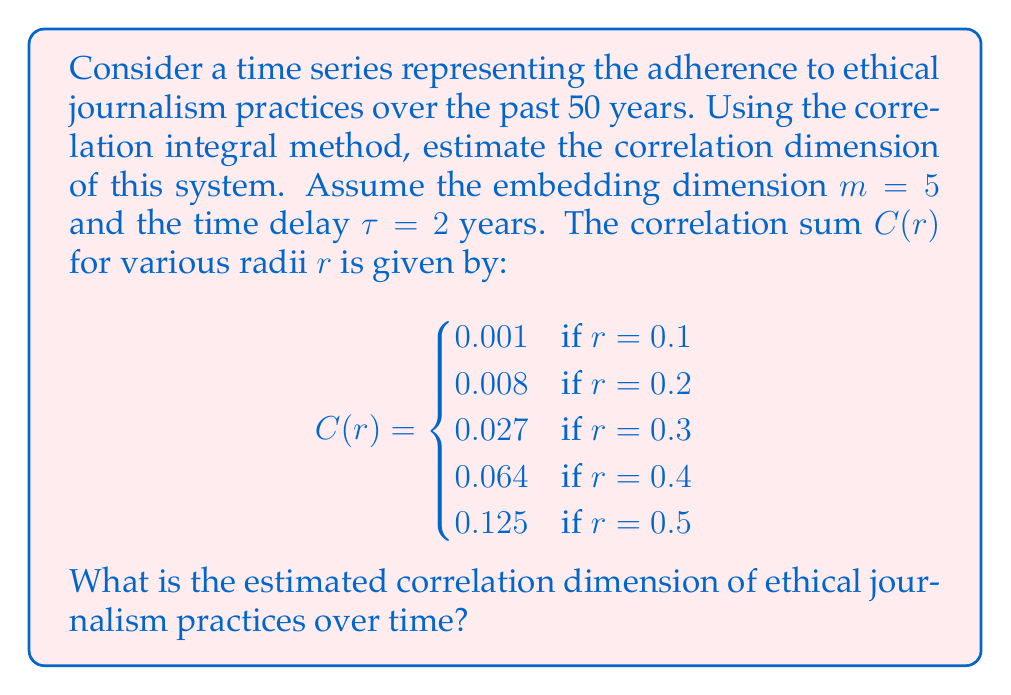Teach me how to tackle this problem. To estimate the correlation dimension, we'll follow these steps:

1) The correlation dimension $D_2$ is defined as:

   $$D_2 = \lim_{r \to 0} \frac{\log C(r)}{\log r}$$

2) In practice, we estimate this by plotting $\log C(r)$ against $\log r$ and finding the slope of the linear portion.

3) Let's calculate $\log C(r)$ and $\log r$ for each given point:

   $$\begin{array}{c|c|c}
   r & \log r & \log C(r) \\
   \hline
   0.1 & -2.3026 & -6.9078 \\
   0.2 & -1.6094 & -4.8283 \\
   0.3 & -1.2040 & -3.6119 \\
   0.4 & -0.9163 & -2.7489 \\
   0.5 & -0.6931 & -2.0794
   \end{array}$$

4) Now, we can estimate the slope using the first and last points:

   $$\text{Slope} = \frac{\Delta \log C(r)}{\Delta \log r} = \frac{-2.0794 - (-6.9078)}{-0.6931 - (-2.3026)} = \frac{4.8284}{1.6095} \approx 3.00$$

5) This slope gives us our estimated correlation dimension.
Answer: $D_2 \approx 3.00$ 